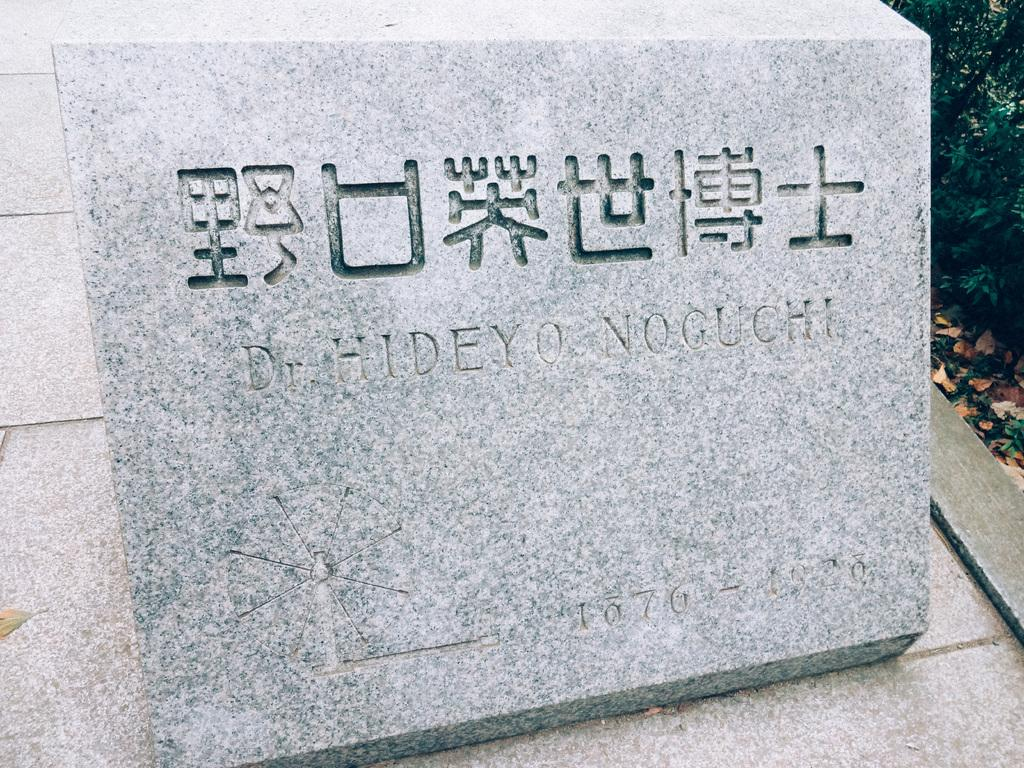What is the main object in the image? There is a rock in the image. What is written or depicted on the rock? There is text on the rock. What type of vegetation is on the right side of the image? There are plants on the right side of the image. What song is being sung by the representative in the image? There is no representative or song present in the image; it features a rock with text and plants. 